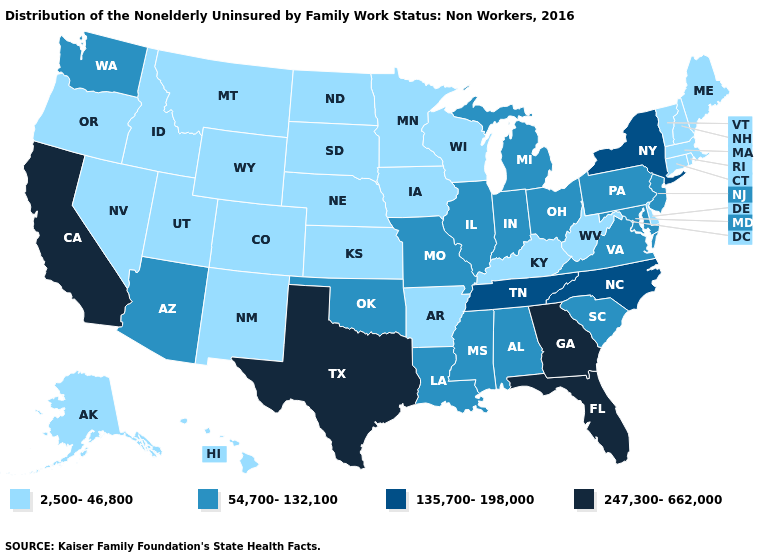What is the lowest value in the USA?
Quick response, please. 2,500-46,800. Name the states that have a value in the range 54,700-132,100?
Short answer required. Alabama, Arizona, Illinois, Indiana, Louisiana, Maryland, Michigan, Mississippi, Missouri, New Jersey, Ohio, Oklahoma, Pennsylvania, South Carolina, Virginia, Washington. Does the first symbol in the legend represent the smallest category?
Keep it brief. Yes. Which states have the highest value in the USA?
Quick response, please. California, Florida, Georgia, Texas. Does New Mexico have the lowest value in the USA?
Keep it brief. Yes. What is the value of Tennessee?
Quick response, please. 135,700-198,000. What is the value of New Mexico?
Answer briefly. 2,500-46,800. What is the value of Pennsylvania?
Quick response, please. 54,700-132,100. Which states have the lowest value in the Northeast?
Be succinct. Connecticut, Maine, Massachusetts, New Hampshire, Rhode Island, Vermont. Does the first symbol in the legend represent the smallest category?
Keep it brief. Yes. What is the value of Rhode Island?
Give a very brief answer. 2,500-46,800. Name the states that have a value in the range 135,700-198,000?
Be succinct. New York, North Carolina, Tennessee. What is the lowest value in the USA?
Concise answer only. 2,500-46,800. What is the highest value in the USA?
Keep it brief. 247,300-662,000. How many symbols are there in the legend?
Answer briefly. 4. 